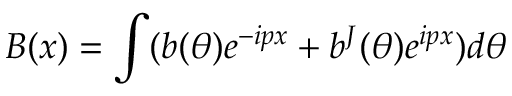Convert formula to latex. <formula><loc_0><loc_0><loc_500><loc_500>B ( x ) = \int ( b ( \theta ) e ^ { - i p x } + b ^ { J } ( \theta ) e ^ { i p x } ) d \theta</formula> 